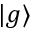Convert formula to latex. <formula><loc_0><loc_0><loc_500><loc_500>| g \rangle</formula> 